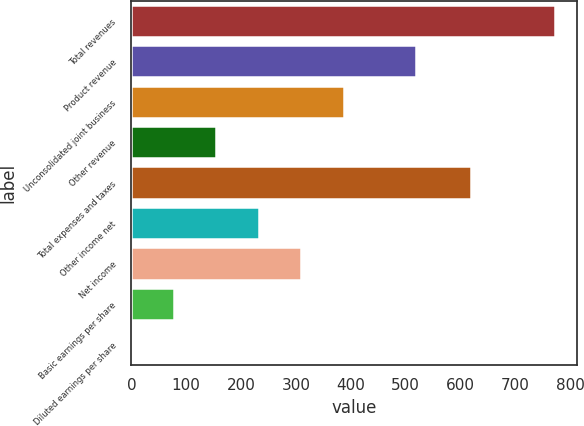<chart> <loc_0><loc_0><loc_500><loc_500><bar_chart><fcel>Total revenues<fcel>Product revenue<fcel>Unconsolidated joint business<fcel>Other revenue<fcel>Total expenses and taxes<fcel>Other income net<fcel>Net income<fcel>Basic earnings per share<fcel>Diluted earnings per share<nl><fcel>773.2<fcel>518.6<fcel>386.89<fcel>155.08<fcel>618.6<fcel>232.35<fcel>309.62<fcel>77.81<fcel>0.54<nl></chart> 